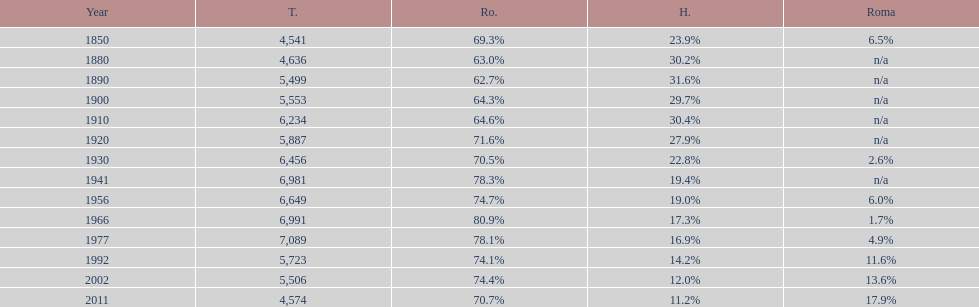In what year was there the largest percentage of hungarians? 1890. 